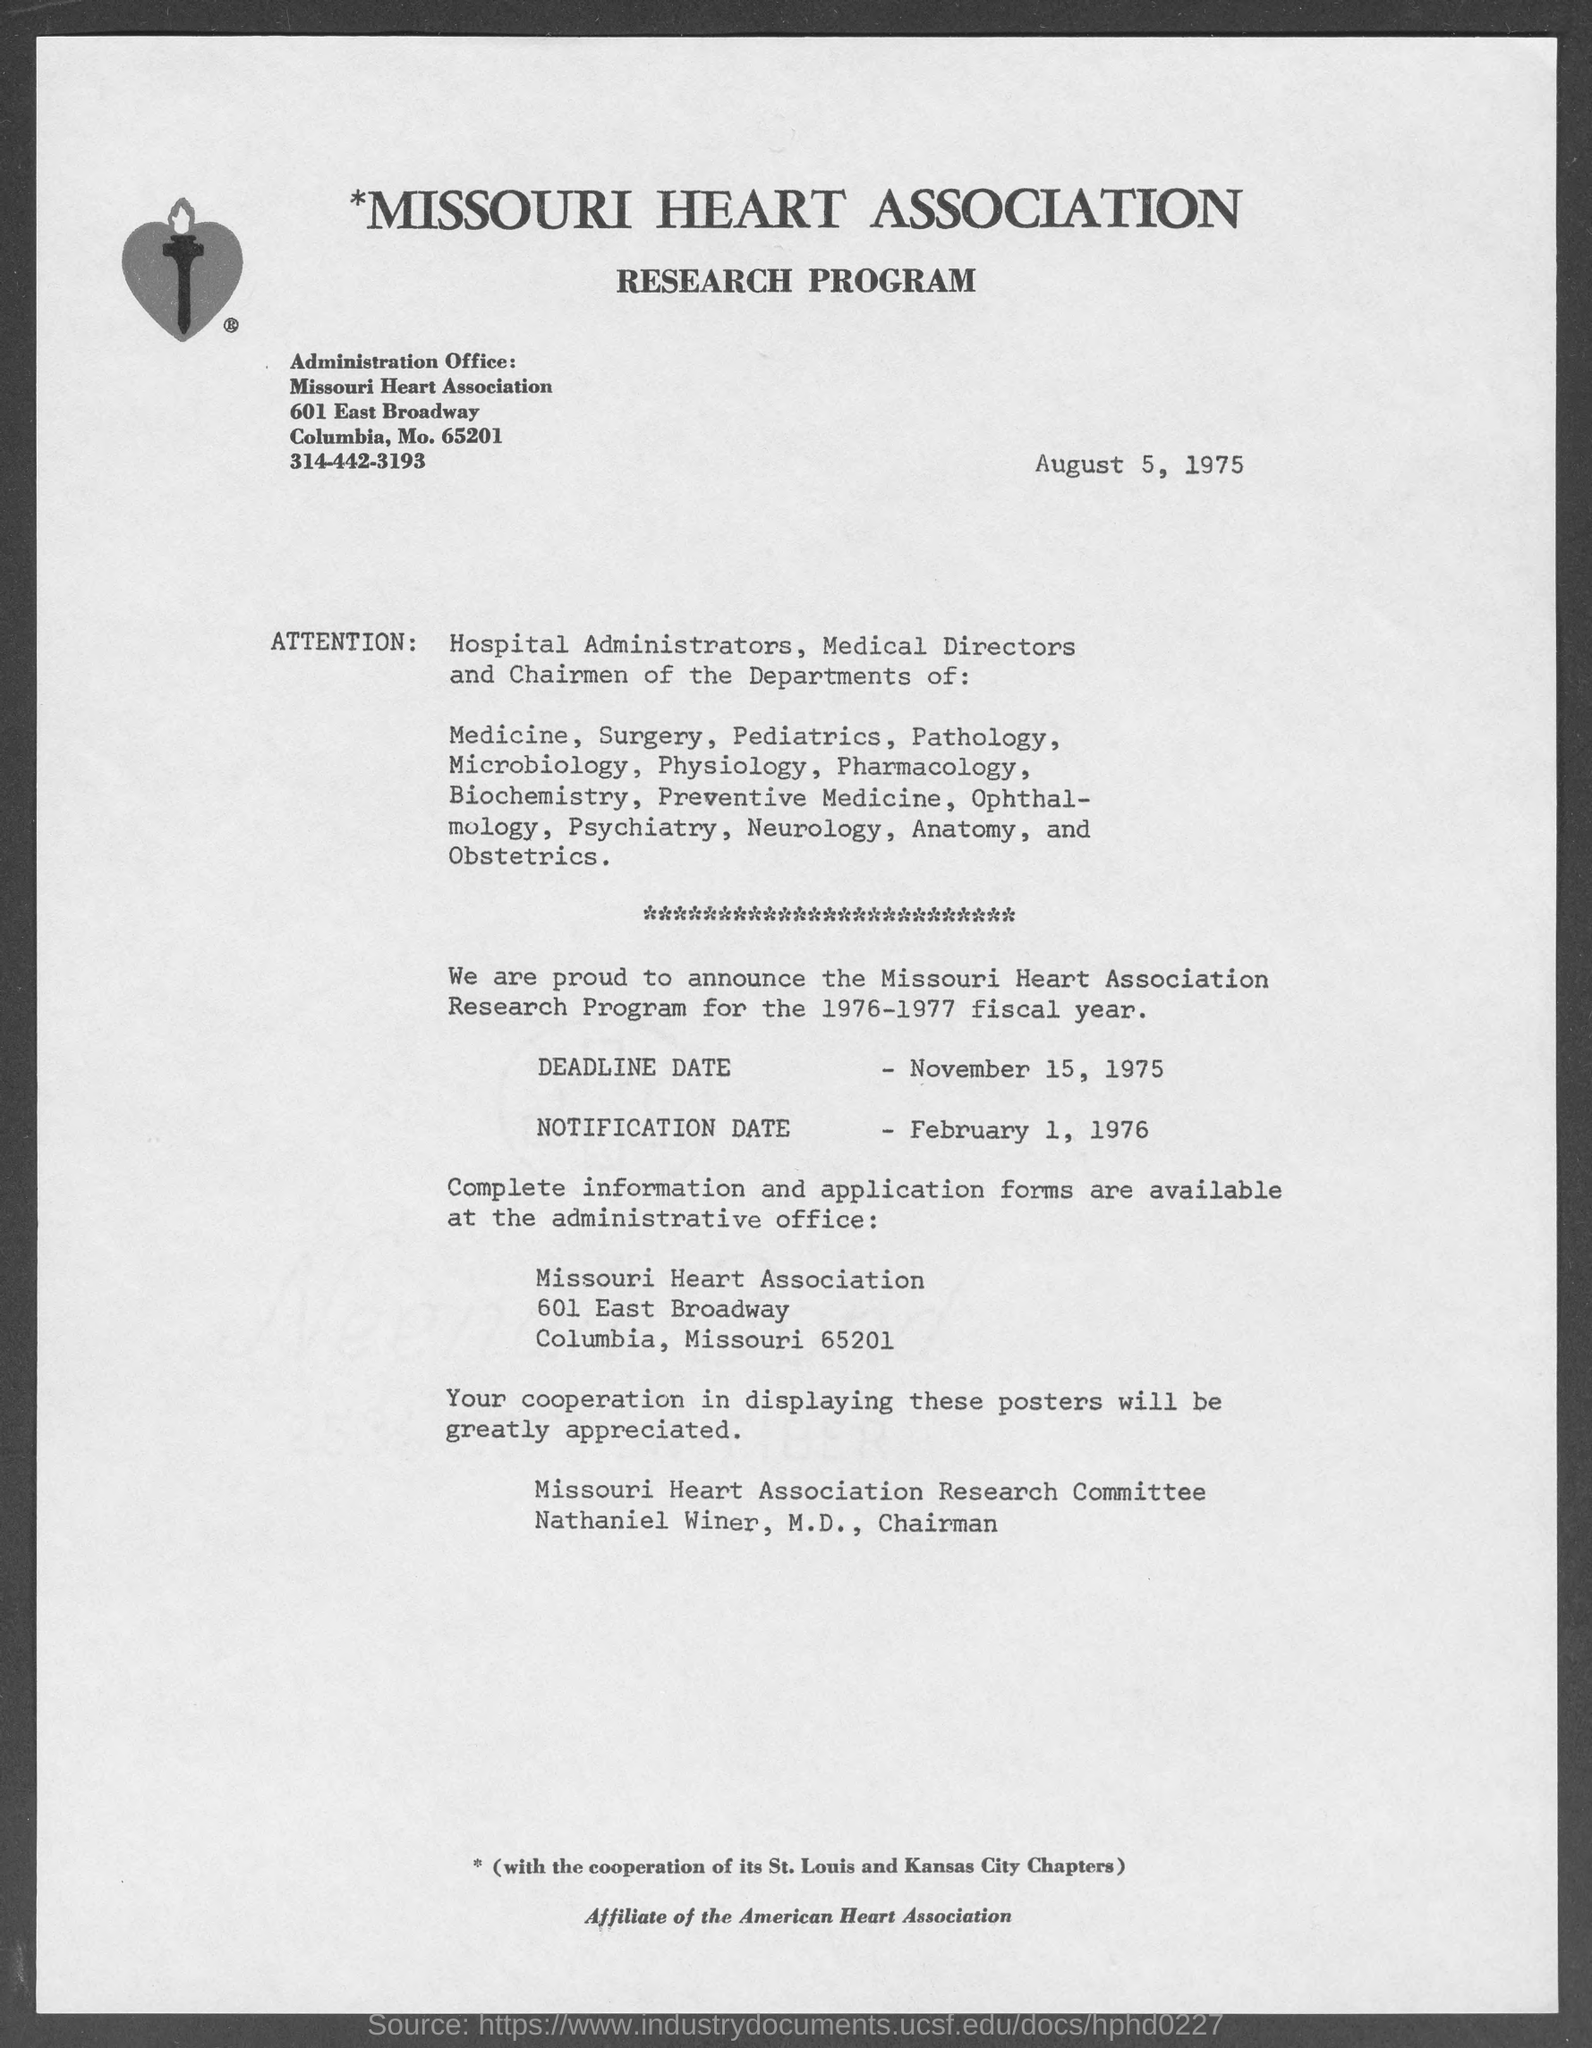What is the notification date for 1976-1977 fiscal year?
Offer a very short reply. February 1, 1976. Research program  is posted on which date?
Offer a very short reply. August 5, 1975. Who is the chairman of missouri heart association research committee?
Give a very brief answer. Nathaniel Winer, M.D. 